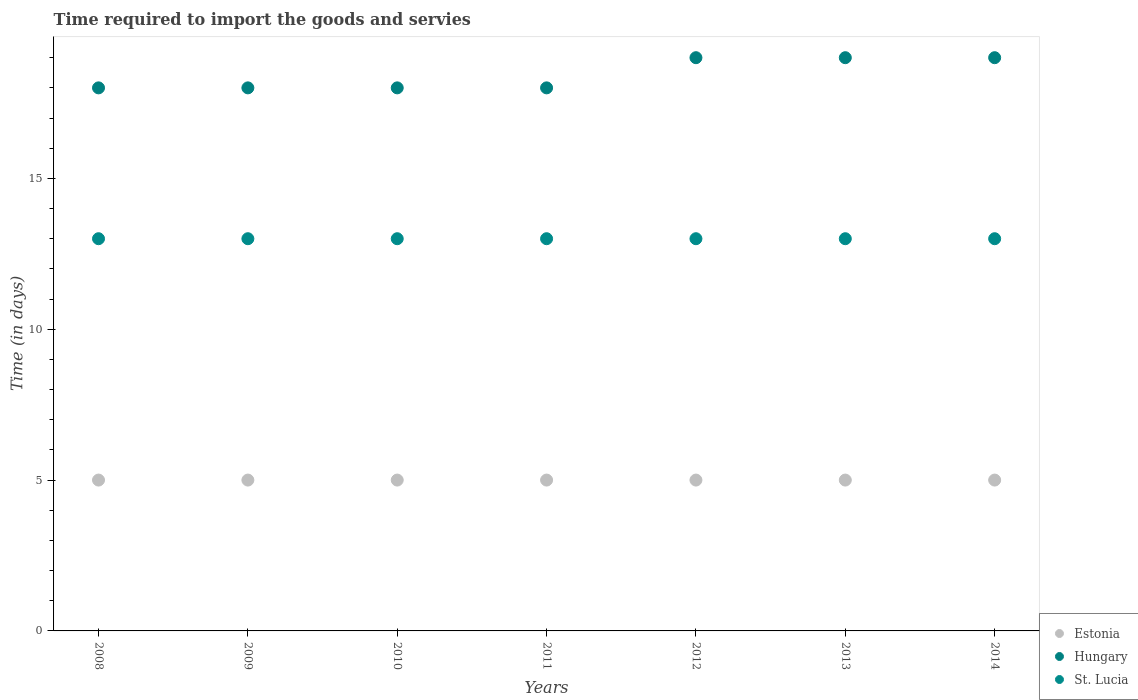How many different coloured dotlines are there?
Keep it short and to the point. 3. Is the number of dotlines equal to the number of legend labels?
Offer a terse response. Yes. What is the number of days required to import the goods and services in Hungary in 2014?
Provide a succinct answer. 19. Across all years, what is the maximum number of days required to import the goods and services in Hungary?
Keep it short and to the point. 19. Across all years, what is the minimum number of days required to import the goods and services in Estonia?
Make the answer very short. 5. What is the total number of days required to import the goods and services in Estonia in the graph?
Your answer should be very brief. 35. What is the difference between the number of days required to import the goods and services in Estonia in 2008 and that in 2013?
Ensure brevity in your answer.  0. What is the difference between the number of days required to import the goods and services in St. Lucia in 2013 and the number of days required to import the goods and services in Hungary in 2008?
Provide a short and direct response. -5. What is the average number of days required to import the goods and services in Estonia per year?
Offer a terse response. 5. In the year 2009, what is the difference between the number of days required to import the goods and services in Hungary and number of days required to import the goods and services in St. Lucia?
Offer a very short reply. 5. In how many years, is the number of days required to import the goods and services in St. Lucia greater than 9 days?
Offer a very short reply. 7. What is the difference between the highest and the second highest number of days required to import the goods and services in Hungary?
Provide a succinct answer. 0. In how many years, is the number of days required to import the goods and services in Hungary greater than the average number of days required to import the goods and services in Hungary taken over all years?
Keep it short and to the point. 3. Is it the case that in every year, the sum of the number of days required to import the goods and services in Estonia and number of days required to import the goods and services in Hungary  is greater than the number of days required to import the goods and services in St. Lucia?
Give a very brief answer. Yes. Does the number of days required to import the goods and services in Estonia monotonically increase over the years?
Give a very brief answer. No. Is the number of days required to import the goods and services in Hungary strictly greater than the number of days required to import the goods and services in St. Lucia over the years?
Ensure brevity in your answer.  Yes. Is the number of days required to import the goods and services in Hungary strictly less than the number of days required to import the goods and services in Estonia over the years?
Give a very brief answer. No. How many dotlines are there?
Provide a short and direct response. 3. How many years are there in the graph?
Your answer should be compact. 7. What is the difference between two consecutive major ticks on the Y-axis?
Your answer should be very brief. 5. Where does the legend appear in the graph?
Give a very brief answer. Bottom right. How many legend labels are there?
Offer a terse response. 3. What is the title of the graph?
Give a very brief answer. Time required to import the goods and servies. What is the label or title of the X-axis?
Keep it short and to the point. Years. What is the label or title of the Y-axis?
Your answer should be compact. Time (in days). What is the Time (in days) in Estonia in 2008?
Give a very brief answer. 5. What is the Time (in days) in Hungary in 2008?
Make the answer very short. 18. What is the Time (in days) of St. Lucia in 2008?
Your answer should be compact. 13. What is the Time (in days) of Estonia in 2009?
Your answer should be compact. 5. What is the Time (in days) in St. Lucia in 2009?
Give a very brief answer. 13. What is the Time (in days) in Estonia in 2010?
Provide a short and direct response. 5. What is the Time (in days) of St. Lucia in 2010?
Give a very brief answer. 13. What is the Time (in days) of Estonia in 2011?
Provide a succinct answer. 5. What is the Time (in days) in St. Lucia in 2011?
Provide a short and direct response. 13. What is the Time (in days) of Estonia in 2012?
Make the answer very short. 5. What is the Time (in days) in St. Lucia in 2012?
Provide a short and direct response. 13. What is the Time (in days) in Estonia in 2014?
Keep it short and to the point. 5. What is the Time (in days) of St. Lucia in 2014?
Make the answer very short. 13. Across all years, what is the maximum Time (in days) in Estonia?
Provide a succinct answer. 5. Across all years, what is the minimum Time (in days) of Estonia?
Provide a short and direct response. 5. Across all years, what is the minimum Time (in days) of St. Lucia?
Give a very brief answer. 13. What is the total Time (in days) of Hungary in the graph?
Give a very brief answer. 129. What is the total Time (in days) in St. Lucia in the graph?
Keep it short and to the point. 91. What is the difference between the Time (in days) in Estonia in 2008 and that in 2009?
Give a very brief answer. 0. What is the difference between the Time (in days) of St. Lucia in 2008 and that in 2009?
Provide a succinct answer. 0. What is the difference between the Time (in days) in Estonia in 2008 and that in 2010?
Your answer should be very brief. 0. What is the difference between the Time (in days) of St. Lucia in 2008 and that in 2011?
Your answer should be compact. 0. What is the difference between the Time (in days) in Estonia in 2008 and that in 2012?
Your answer should be compact. 0. What is the difference between the Time (in days) of Hungary in 2008 and that in 2012?
Your answer should be compact. -1. What is the difference between the Time (in days) of St. Lucia in 2008 and that in 2012?
Provide a short and direct response. 0. What is the difference between the Time (in days) in Estonia in 2008 and that in 2013?
Your answer should be very brief. 0. What is the difference between the Time (in days) in Hungary in 2008 and that in 2014?
Your response must be concise. -1. What is the difference between the Time (in days) in Hungary in 2009 and that in 2011?
Provide a short and direct response. 0. What is the difference between the Time (in days) in St. Lucia in 2009 and that in 2011?
Offer a terse response. 0. What is the difference between the Time (in days) in Hungary in 2009 and that in 2012?
Provide a succinct answer. -1. What is the difference between the Time (in days) in Estonia in 2009 and that in 2013?
Offer a very short reply. 0. What is the difference between the Time (in days) of St. Lucia in 2009 and that in 2013?
Offer a very short reply. 0. What is the difference between the Time (in days) of Hungary in 2009 and that in 2014?
Ensure brevity in your answer.  -1. What is the difference between the Time (in days) in Estonia in 2010 and that in 2011?
Make the answer very short. 0. What is the difference between the Time (in days) of St. Lucia in 2010 and that in 2011?
Give a very brief answer. 0. What is the difference between the Time (in days) of Hungary in 2010 and that in 2012?
Offer a very short reply. -1. What is the difference between the Time (in days) in St. Lucia in 2010 and that in 2012?
Your response must be concise. 0. What is the difference between the Time (in days) in Hungary in 2010 and that in 2013?
Make the answer very short. -1. What is the difference between the Time (in days) of St. Lucia in 2010 and that in 2013?
Your response must be concise. 0. What is the difference between the Time (in days) in Estonia in 2010 and that in 2014?
Offer a terse response. 0. What is the difference between the Time (in days) of Hungary in 2011 and that in 2012?
Make the answer very short. -1. What is the difference between the Time (in days) of Hungary in 2011 and that in 2013?
Give a very brief answer. -1. What is the difference between the Time (in days) in Estonia in 2012 and that in 2014?
Give a very brief answer. 0. What is the difference between the Time (in days) of Hungary in 2012 and that in 2014?
Your answer should be very brief. 0. What is the difference between the Time (in days) in Hungary in 2013 and that in 2014?
Your answer should be very brief. 0. What is the difference between the Time (in days) of Estonia in 2008 and the Time (in days) of Hungary in 2009?
Offer a terse response. -13. What is the difference between the Time (in days) of Hungary in 2008 and the Time (in days) of St. Lucia in 2009?
Offer a very short reply. 5. What is the difference between the Time (in days) of Estonia in 2008 and the Time (in days) of Hungary in 2010?
Give a very brief answer. -13. What is the difference between the Time (in days) in Estonia in 2008 and the Time (in days) in Hungary in 2011?
Ensure brevity in your answer.  -13. What is the difference between the Time (in days) of Estonia in 2008 and the Time (in days) of St. Lucia in 2011?
Your answer should be very brief. -8. What is the difference between the Time (in days) of Estonia in 2008 and the Time (in days) of Hungary in 2012?
Make the answer very short. -14. What is the difference between the Time (in days) in Estonia in 2008 and the Time (in days) in St. Lucia in 2012?
Offer a terse response. -8. What is the difference between the Time (in days) in Estonia in 2008 and the Time (in days) in Hungary in 2013?
Offer a terse response. -14. What is the difference between the Time (in days) in Hungary in 2008 and the Time (in days) in St. Lucia in 2013?
Your answer should be very brief. 5. What is the difference between the Time (in days) in Hungary in 2008 and the Time (in days) in St. Lucia in 2014?
Your answer should be very brief. 5. What is the difference between the Time (in days) in Estonia in 2009 and the Time (in days) in Hungary in 2010?
Offer a very short reply. -13. What is the difference between the Time (in days) of Estonia in 2009 and the Time (in days) of St. Lucia in 2010?
Provide a short and direct response. -8. What is the difference between the Time (in days) of Hungary in 2009 and the Time (in days) of St. Lucia in 2010?
Your answer should be very brief. 5. What is the difference between the Time (in days) of Estonia in 2009 and the Time (in days) of Hungary in 2011?
Your answer should be very brief. -13. What is the difference between the Time (in days) of Estonia in 2009 and the Time (in days) of St. Lucia in 2011?
Your response must be concise. -8. What is the difference between the Time (in days) in Hungary in 2009 and the Time (in days) in St. Lucia in 2011?
Provide a short and direct response. 5. What is the difference between the Time (in days) in Estonia in 2009 and the Time (in days) in Hungary in 2012?
Ensure brevity in your answer.  -14. What is the difference between the Time (in days) of Estonia in 2009 and the Time (in days) of Hungary in 2013?
Your response must be concise. -14. What is the difference between the Time (in days) in Estonia in 2009 and the Time (in days) in Hungary in 2014?
Offer a terse response. -14. What is the difference between the Time (in days) of Estonia in 2010 and the Time (in days) of St. Lucia in 2011?
Provide a short and direct response. -8. What is the difference between the Time (in days) in Hungary in 2010 and the Time (in days) in St. Lucia in 2011?
Keep it short and to the point. 5. What is the difference between the Time (in days) of Estonia in 2010 and the Time (in days) of St. Lucia in 2012?
Your answer should be very brief. -8. What is the difference between the Time (in days) in Hungary in 2010 and the Time (in days) in St. Lucia in 2012?
Your response must be concise. 5. What is the difference between the Time (in days) in Hungary in 2010 and the Time (in days) in St. Lucia in 2014?
Give a very brief answer. 5. What is the difference between the Time (in days) of Estonia in 2011 and the Time (in days) of Hungary in 2013?
Make the answer very short. -14. What is the difference between the Time (in days) in Estonia in 2011 and the Time (in days) in St. Lucia in 2014?
Provide a succinct answer. -8. What is the difference between the Time (in days) of Hungary in 2011 and the Time (in days) of St. Lucia in 2014?
Offer a terse response. 5. What is the difference between the Time (in days) in Estonia in 2012 and the Time (in days) in St. Lucia in 2013?
Offer a terse response. -8. What is the difference between the Time (in days) in Estonia in 2012 and the Time (in days) in Hungary in 2014?
Offer a terse response. -14. What is the difference between the Time (in days) in Estonia in 2012 and the Time (in days) in St. Lucia in 2014?
Offer a terse response. -8. What is the difference between the Time (in days) of Hungary in 2012 and the Time (in days) of St. Lucia in 2014?
Ensure brevity in your answer.  6. What is the difference between the Time (in days) of Estonia in 2013 and the Time (in days) of Hungary in 2014?
Give a very brief answer. -14. What is the difference between the Time (in days) of Hungary in 2013 and the Time (in days) of St. Lucia in 2014?
Provide a succinct answer. 6. What is the average Time (in days) of Hungary per year?
Provide a short and direct response. 18.43. In the year 2008, what is the difference between the Time (in days) in Estonia and Time (in days) in Hungary?
Ensure brevity in your answer.  -13. In the year 2008, what is the difference between the Time (in days) of Hungary and Time (in days) of St. Lucia?
Provide a succinct answer. 5. In the year 2009, what is the difference between the Time (in days) of Estonia and Time (in days) of Hungary?
Your response must be concise. -13. In the year 2009, what is the difference between the Time (in days) in Hungary and Time (in days) in St. Lucia?
Give a very brief answer. 5. In the year 2010, what is the difference between the Time (in days) in Estonia and Time (in days) in Hungary?
Keep it short and to the point. -13. In the year 2010, what is the difference between the Time (in days) of Estonia and Time (in days) of St. Lucia?
Provide a succinct answer. -8. In the year 2011, what is the difference between the Time (in days) of Estonia and Time (in days) of St. Lucia?
Provide a short and direct response. -8. In the year 2011, what is the difference between the Time (in days) in Hungary and Time (in days) in St. Lucia?
Offer a terse response. 5. In the year 2012, what is the difference between the Time (in days) in Estonia and Time (in days) in Hungary?
Offer a very short reply. -14. In the year 2012, what is the difference between the Time (in days) of Hungary and Time (in days) of St. Lucia?
Give a very brief answer. 6. In the year 2013, what is the difference between the Time (in days) in Estonia and Time (in days) in Hungary?
Make the answer very short. -14. In the year 2013, what is the difference between the Time (in days) in Estonia and Time (in days) in St. Lucia?
Give a very brief answer. -8. In the year 2013, what is the difference between the Time (in days) in Hungary and Time (in days) in St. Lucia?
Provide a short and direct response. 6. In the year 2014, what is the difference between the Time (in days) in Estonia and Time (in days) in Hungary?
Provide a short and direct response. -14. What is the ratio of the Time (in days) of Hungary in 2008 to that in 2009?
Provide a succinct answer. 1. What is the ratio of the Time (in days) in Hungary in 2008 to that in 2010?
Your response must be concise. 1. What is the ratio of the Time (in days) of St. Lucia in 2008 to that in 2010?
Keep it short and to the point. 1. What is the ratio of the Time (in days) of Estonia in 2008 to that in 2011?
Offer a very short reply. 1. What is the ratio of the Time (in days) in Hungary in 2008 to that in 2011?
Make the answer very short. 1. What is the ratio of the Time (in days) of St. Lucia in 2008 to that in 2011?
Offer a terse response. 1. What is the ratio of the Time (in days) in Estonia in 2008 to that in 2012?
Provide a succinct answer. 1. What is the ratio of the Time (in days) of St. Lucia in 2008 to that in 2012?
Offer a very short reply. 1. What is the ratio of the Time (in days) in Estonia in 2008 to that in 2013?
Your answer should be very brief. 1. What is the ratio of the Time (in days) in St. Lucia in 2008 to that in 2013?
Make the answer very short. 1. What is the ratio of the Time (in days) in Hungary in 2008 to that in 2014?
Your response must be concise. 0.95. What is the ratio of the Time (in days) of Estonia in 2009 to that in 2010?
Provide a short and direct response. 1. What is the ratio of the Time (in days) in Hungary in 2009 to that in 2010?
Give a very brief answer. 1. What is the ratio of the Time (in days) in St. Lucia in 2009 to that in 2010?
Provide a short and direct response. 1. What is the ratio of the Time (in days) in St. Lucia in 2009 to that in 2011?
Give a very brief answer. 1. What is the ratio of the Time (in days) in Hungary in 2009 to that in 2012?
Offer a terse response. 0.95. What is the ratio of the Time (in days) of St. Lucia in 2009 to that in 2012?
Provide a succinct answer. 1. What is the ratio of the Time (in days) of Estonia in 2009 to that in 2013?
Offer a very short reply. 1. What is the ratio of the Time (in days) of Estonia in 2009 to that in 2014?
Offer a very short reply. 1. What is the ratio of the Time (in days) in Hungary in 2009 to that in 2014?
Ensure brevity in your answer.  0.95. What is the ratio of the Time (in days) in St. Lucia in 2009 to that in 2014?
Keep it short and to the point. 1. What is the ratio of the Time (in days) in Hungary in 2010 to that in 2011?
Your answer should be compact. 1. What is the ratio of the Time (in days) in Estonia in 2010 to that in 2012?
Your response must be concise. 1. What is the ratio of the Time (in days) in Hungary in 2010 to that in 2012?
Your answer should be compact. 0.95. What is the ratio of the Time (in days) in St. Lucia in 2010 to that in 2012?
Your answer should be compact. 1. What is the ratio of the Time (in days) of Estonia in 2010 to that in 2014?
Make the answer very short. 1. What is the ratio of the Time (in days) of Hungary in 2010 to that in 2014?
Provide a succinct answer. 0.95. What is the ratio of the Time (in days) of Estonia in 2011 to that in 2012?
Offer a very short reply. 1. What is the ratio of the Time (in days) in Hungary in 2011 to that in 2013?
Your response must be concise. 0.95. What is the ratio of the Time (in days) in St. Lucia in 2011 to that in 2013?
Provide a short and direct response. 1. What is the ratio of the Time (in days) of Estonia in 2011 to that in 2014?
Give a very brief answer. 1. What is the ratio of the Time (in days) in Hungary in 2011 to that in 2014?
Your response must be concise. 0.95. What is the ratio of the Time (in days) in Hungary in 2012 to that in 2013?
Provide a succinct answer. 1. What is the difference between the highest and the lowest Time (in days) in Estonia?
Keep it short and to the point. 0. What is the difference between the highest and the lowest Time (in days) in Hungary?
Ensure brevity in your answer.  1. 